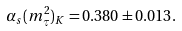Convert formula to latex. <formula><loc_0><loc_0><loc_500><loc_500>\alpha _ { s } ( m _ { \tau } ^ { 2 } ) _ { K } = 0 . 3 8 0 \pm 0 . 0 1 3 .</formula> 